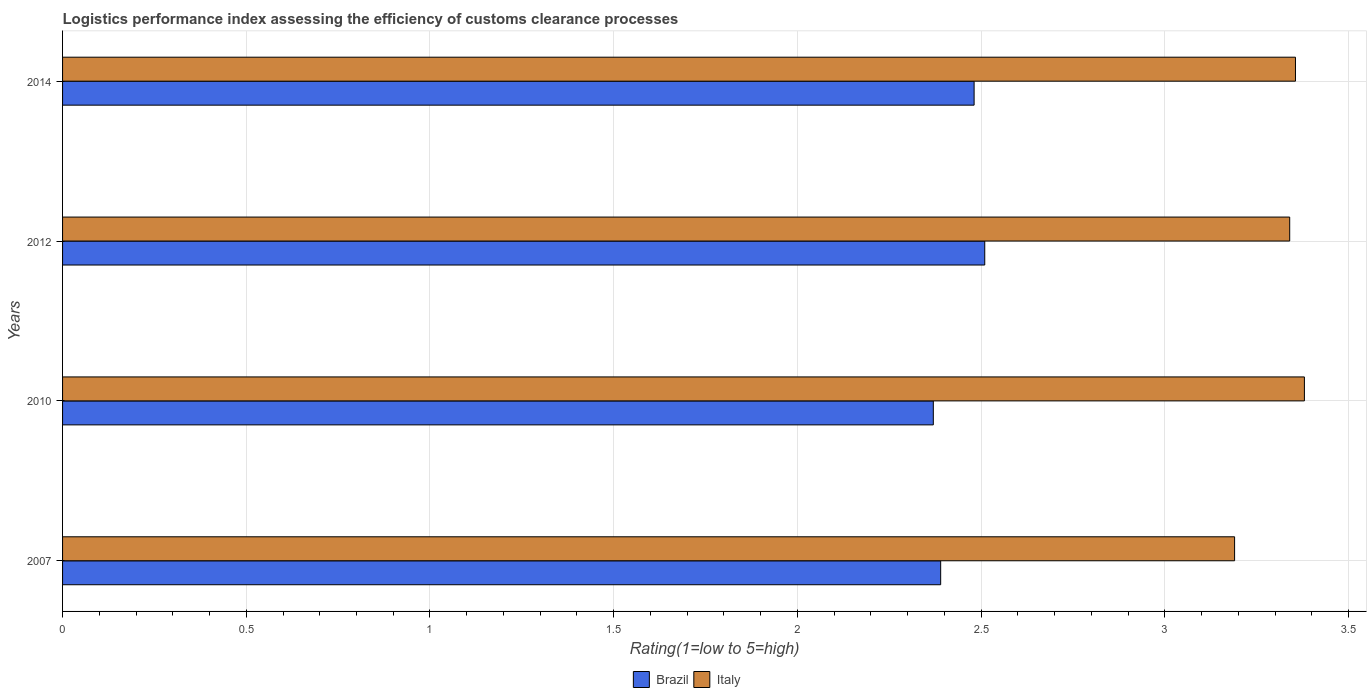How many different coloured bars are there?
Keep it short and to the point. 2. How many groups of bars are there?
Your answer should be compact. 4. What is the label of the 4th group of bars from the top?
Your answer should be compact. 2007. In how many cases, is the number of bars for a given year not equal to the number of legend labels?
Your answer should be very brief. 0. What is the Logistic performance index in Brazil in 2012?
Make the answer very short. 2.51. Across all years, what is the maximum Logistic performance index in Italy?
Provide a succinct answer. 3.38. Across all years, what is the minimum Logistic performance index in Italy?
Ensure brevity in your answer.  3.19. In which year was the Logistic performance index in Brazil maximum?
Your answer should be very brief. 2012. In which year was the Logistic performance index in Brazil minimum?
Give a very brief answer. 2010. What is the total Logistic performance index in Brazil in the graph?
Provide a short and direct response. 9.75. What is the difference between the Logistic performance index in Brazil in 2012 and that in 2014?
Your answer should be very brief. 0.03. What is the difference between the Logistic performance index in Italy in 2007 and the Logistic performance index in Brazil in 2012?
Your answer should be compact. 0.68. What is the average Logistic performance index in Brazil per year?
Keep it short and to the point. 2.44. In the year 2014, what is the difference between the Logistic performance index in Italy and Logistic performance index in Brazil?
Offer a very short reply. 0.87. In how many years, is the Logistic performance index in Italy greater than 2.6 ?
Make the answer very short. 4. What is the ratio of the Logistic performance index in Brazil in 2007 to that in 2012?
Offer a very short reply. 0.95. Is the Logistic performance index in Brazil in 2012 less than that in 2014?
Your answer should be very brief. No. What is the difference between the highest and the second highest Logistic performance index in Brazil?
Keep it short and to the point. 0.03. What is the difference between the highest and the lowest Logistic performance index in Brazil?
Offer a very short reply. 0.14. Is the sum of the Logistic performance index in Brazil in 2012 and 2014 greater than the maximum Logistic performance index in Italy across all years?
Provide a succinct answer. Yes. What does the 2nd bar from the top in 2012 represents?
Offer a very short reply. Brazil. What does the 1st bar from the bottom in 2014 represents?
Your answer should be very brief. Brazil. Are all the bars in the graph horizontal?
Give a very brief answer. Yes. How many years are there in the graph?
Give a very brief answer. 4. What is the difference between two consecutive major ticks on the X-axis?
Give a very brief answer. 0.5. Are the values on the major ticks of X-axis written in scientific E-notation?
Offer a terse response. No. How many legend labels are there?
Keep it short and to the point. 2. What is the title of the graph?
Keep it short and to the point. Logistics performance index assessing the efficiency of customs clearance processes. What is the label or title of the X-axis?
Make the answer very short. Rating(1=low to 5=high). What is the Rating(1=low to 5=high) in Brazil in 2007?
Offer a terse response. 2.39. What is the Rating(1=low to 5=high) of Italy in 2007?
Ensure brevity in your answer.  3.19. What is the Rating(1=low to 5=high) of Brazil in 2010?
Offer a terse response. 2.37. What is the Rating(1=low to 5=high) in Italy in 2010?
Provide a short and direct response. 3.38. What is the Rating(1=low to 5=high) in Brazil in 2012?
Your answer should be compact. 2.51. What is the Rating(1=low to 5=high) of Italy in 2012?
Offer a terse response. 3.34. What is the Rating(1=low to 5=high) in Brazil in 2014?
Keep it short and to the point. 2.48. What is the Rating(1=low to 5=high) of Italy in 2014?
Offer a very short reply. 3.36. Across all years, what is the maximum Rating(1=low to 5=high) of Brazil?
Provide a succinct answer. 2.51. Across all years, what is the maximum Rating(1=low to 5=high) of Italy?
Provide a short and direct response. 3.38. Across all years, what is the minimum Rating(1=low to 5=high) in Brazil?
Offer a very short reply. 2.37. Across all years, what is the minimum Rating(1=low to 5=high) in Italy?
Offer a very short reply. 3.19. What is the total Rating(1=low to 5=high) of Brazil in the graph?
Give a very brief answer. 9.75. What is the total Rating(1=low to 5=high) in Italy in the graph?
Your response must be concise. 13.27. What is the difference between the Rating(1=low to 5=high) of Italy in 2007 and that in 2010?
Keep it short and to the point. -0.19. What is the difference between the Rating(1=low to 5=high) in Brazil in 2007 and that in 2012?
Make the answer very short. -0.12. What is the difference between the Rating(1=low to 5=high) of Italy in 2007 and that in 2012?
Make the answer very short. -0.15. What is the difference between the Rating(1=low to 5=high) in Brazil in 2007 and that in 2014?
Offer a very short reply. -0.09. What is the difference between the Rating(1=low to 5=high) of Italy in 2007 and that in 2014?
Offer a terse response. -0.17. What is the difference between the Rating(1=low to 5=high) of Brazil in 2010 and that in 2012?
Your response must be concise. -0.14. What is the difference between the Rating(1=low to 5=high) of Brazil in 2010 and that in 2014?
Offer a terse response. -0.11. What is the difference between the Rating(1=low to 5=high) of Italy in 2010 and that in 2014?
Offer a terse response. 0.02. What is the difference between the Rating(1=low to 5=high) of Brazil in 2012 and that in 2014?
Your response must be concise. 0.03. What is the difference between the Rating(1=low to 5=high) in Italy in 2012 and that in 2014?
Your response must be concise. -0.02. What is the difference between the Rating(1=low to 5=high) in Brazil in 2007 and the Rating(1=low to 5=high) in Italy in 2010?
Offer a terse response. -0.99. What is the difference between the Rating(1=low to 5=high) in Brazil in 2007 and the Rating(1=low to 5=high) in Italy in 2012?
Provide a short and direct response. -0.95. What is the difference between the Rating(1=low to 5=high) of Brazil in 2007 and the Rating(1=low to 5=high) of Italy in 2014?
Your answer should be very brief. -0.97. What is the difference between the Rating(1=low to 5=high) of Brazil in 2010 and the Rating(1=low to 5=high) of Italy in 2012?
Provide a short and direct response. -0.97. What is the difference between the Rating(1=low to 5=high) of Brazil in 2010 and the Rating(1=low to 5=high) of Italy in 2014?
Your response must be concise. -0.99. What is the difference between the Rating(1=low to 5=high) of Brazil in 2012 and the Rating(1=low to 5=high) of Italy in 2014?
Your response must be concise. -0.85. What is the average Rating(1=low to 5=high) in Brazil per year?
Give a very brief answer. 2.44. What is the average Rating(1=low to 5=high) in Italy per year?
Give a very brief answer. 3.32. In the year 2007, what is the difference between the Rating(1=low to 5=high) of Brazil and Rating(1=low to 5=high) of Italy?
Offer a terse response. -0.8. In the year 2010, what is the difference between the Rating(1=low to 5=high) in Brazil and Rating(1=low to 5=high) in Italy?
Make the answer very short. -1.01. In the year 2012, what is the difference between the Rating(1=low to 5=high) in Brazil and Rating(1=low to 5=high) in Italy?
Ensure brevity in your answer.  -0.83. In the year 2014, what is the difference between the Rating(1=low to 5=high) of Brazil and Rating(1=low to 5=high) of Italy?
Offer a very short reply. -0.87. What is the ratio of the Rating(1=low to 5=high) of Brazil in 2007 to that in 2010?
Offer a very short reply. 1.01. What is the ratio of the Rating(1=low to 5=high) in Italy in 2007 to that in 2010?
Your answer should be very brief. 0.94. What is the ratio of the Rating(1=low to 5=high) in Brazil in 2007 to that in 2012?
Offer a terse response. 0.95. What is the ratio of the Rating(1=low to 5=high) of Italy in 2007 to that in 2012?
Make the answer very short. 0.96. What is the ratio of the Rating(1=low to 5=high) of Brazil in 2007 to that in 2014?
Make the answer very short. 0.96. What is the ratio of the Rating(1=low to 5=high) in Italy in 2007 to that in 2014?
Offer a terse response. 0.95. What is the ratio of the Rating(1=low to 5=high) in Brazil in 2010 to that in 2012?
Make the answer very short. 0.94. What is the ratio of the Rating(1=low to 5=high) of Italy in 2010 to that in 2012?
Provide a succinct answer. 1.01. What is the ratio of the Rating(1=low to 5=high) of Brazil in 2010 to that in 2014?
Make the answer very short. 0.96. What is the ratio of the Rating(1=low to 5=high) of Brazil in 2012 to that in 2014?
Provide a succinct answer. 1.01. What is the ratio of the Rating(1=low to 5=high) of Italy in 2012 to that in 2014?
Offer a terse response. 1. What is the difference between the highest and the second highest Rating(1=low to 5=high) of Brazil?
Ensure brevity in your answer.  0.03. What is the difference between the highest and the second highest Rating(1=low to 5=high) of Italy?
Offer a very short reply. 0.02. What is the difference between the highest and the lowest Rating(1=low to 5=high) of Brazil?
Your response must be concise. 0.14. What is the difference between the highest and the lowest Rating(1=low to 5=high) in Italy?
Ensure brevity in your answer.  0.19. 